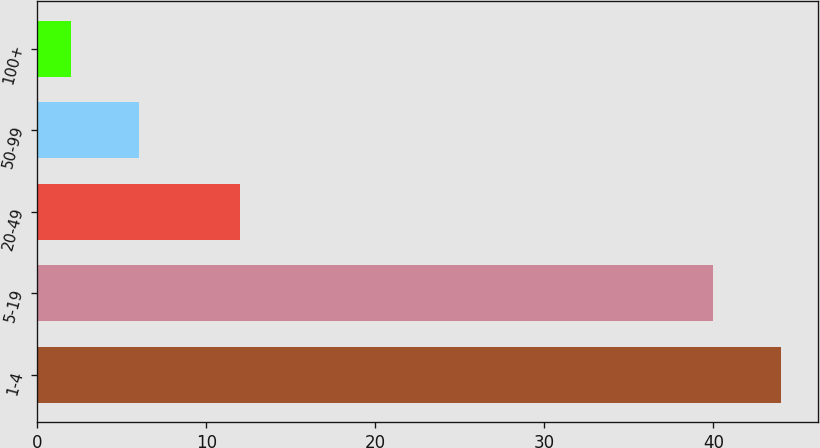Convert chart to OTSL. <chart><loc_0><loc_0><loc_500><loc_500><bar_chart><fcel>1-4<fcel>5-19<fcel>20-49<fcel>50-99<fcel>100+<nl><fcel>44<fcel>40<fcel>12<fcel>6<fcel>2<nl></chart> 